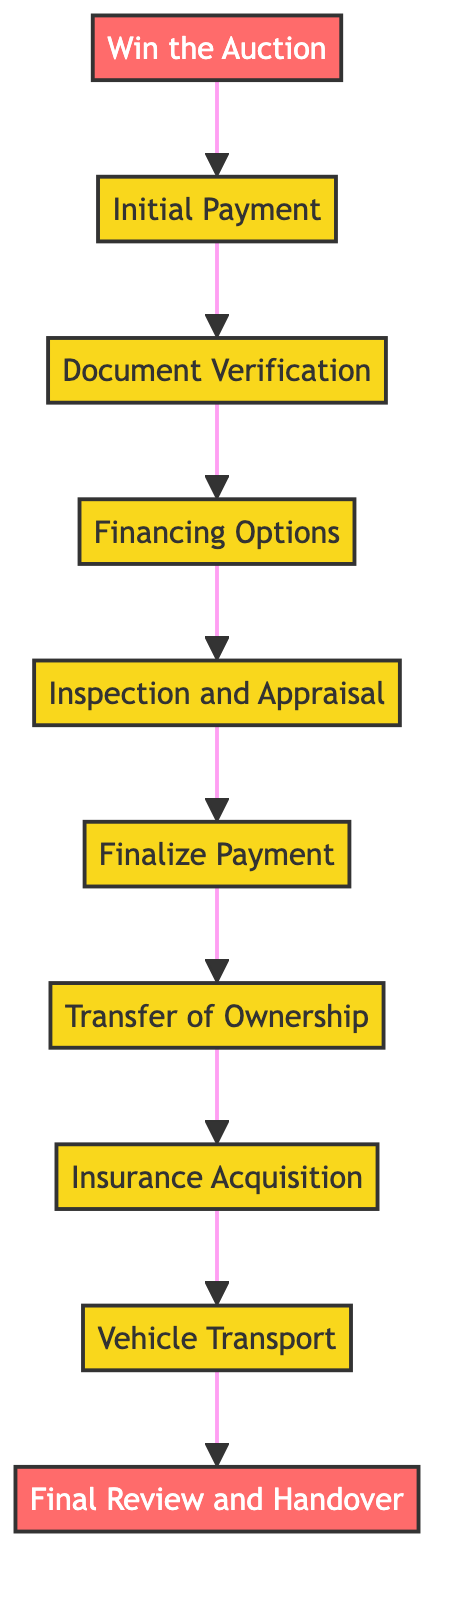What is the first step in the process? The first step in the process is represented by the top node of the diagram, which states "Win the Auction."
Answer: Win the Auction How many steps are there in total? By counting each individual step connected by arrows in the diagram, there are 10 steps laid out in the flow.
Answer: 10 What step comes after "Document Verification"? Looking at the arrows that connect the steps, "Financing Options" is the next step that follows directly after "Document Verification."
Answer: Financing Options Which step requires obtaining insurance coverage? In the flow, the step labeled "Insurance Acquisition" specifically pertains to the process of obtaining insurance for the supercar.
Answer: Insurance Acquisition What is the final step in the process? The last node in the flowchart indicates "Final Review and Handover," which is the concluding action for the supercar buyer.
Answer: Final Review and Handover What step follows "Inspection and Appraisal"? By examining the sequence of steps in the diagram, "Finalize Payment" directly follows "Inspection and Appraisal" in the process.
Answer: Finalize Payment What is the relationship between "Initial Payment" and "Finalize Payment"? "Initial Payment" occurs first and is a prerequisite to "Finalize Payment," indicating it's part of the payment process.
Answer: Initial Payment is a prerequisite What documentation is verified during "Document Verification"? The description specifies verifying documents like the Vehicle Identification Number (VIN), title, and service history in this step.
Answer: VIN, title, service history What is needed if the buyer requires financial assistance? The term "Financing Options" signifies that buyers should explore available financing if they require assistance.
Answer: Financing Options 